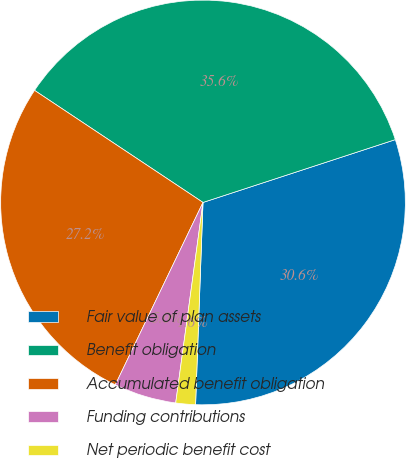Convert chart. <chart><loc_0><loc_0><loc_500><loc_500><pie_chart><fcel>Fair value of plan assets<fcel>Benefit obligation<fcel>Accumulated benefit obligation<fcel>Funding contributions<fcel>Net periodic benefit cost<nl><fcel>30.61%<fcel>35.63%<fcel>27.21%<fcel>4.98%<fcel>1.57%<nl></chart> 